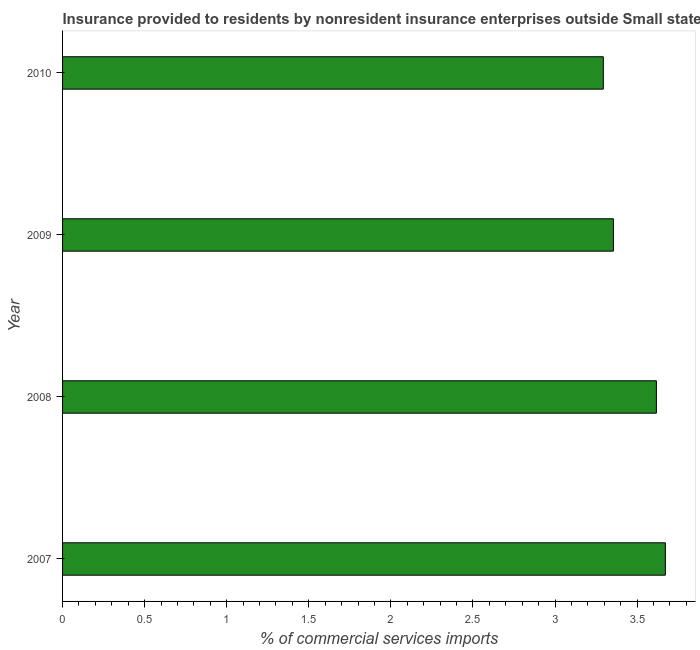What is the title of the graph?
Your response must be concise. Insurance provided to residents by nonresident insurance enterprises outside Small states. What is the label or title of the X-axis?
Make the answer very short. % of commercial services imports. What is the label or title of the Y-axis?
Offer a terse response. Year. What is the insurance provided by non-residents in 2009?
Give a very brief answer. 3.36. Across all years, what is the maximum insurance provided by non-residents?
Your answer should be very brief. 3.67. Across all years, what is the minimum insurance provided by non-residents?
Offer a terse response. 3.29. In which year was the insurance provided by non-residents minimum?
Provide a short and direct response. 2010. What is the sum of the insurance provided by non-residents?
Provide a short and direct response. 13.94. What is the difference between the insurance provided by non-residents in 2008 and 2010?
Keep it short and to the point. 0.32. What is the average insurance provided by non-residents per year?
Provide a short and direct response. 3.48. What is the median insurance provided by non-residents?
Keep it short and to the point. 3.49. In how many years, is the insurance provided by non-residents greater than 0.7 %?
Provide a short and direct response. 4. What is the ratio of the insurance provided by non-residents in 2009 to that in 2010?
Ensure brevity in your answer.  1.02. Is the insurance provided by non-residents in 2007 less than that in 2008?
Ensure brevity in your answer.  No. What is the difference between the highest and the second highest insurance provided by non-residents?
Provide a short and direct response. 0.06. Is the sum of the insurance provided by non-residents in 2009 and 2010 greater than the maximum insurance provided by non-residents across all years?
Provide a succinct answer. Yes. What is the difference between the highest and the lowest insurance provided by non-residents?
Your answer should be very brief. 0.38. What is the difference between two consecutive major ticks on the X-axis?
Offer a terse response. 0.5. What is the % of commercial services imports of 2007?
Make the answer very short. 3.67. What is the % of commercial services imports of 2008?
Make the answer very short. 3.62. What is the % of commercial services imports of 2009?
Your response must be concise. 3.36. What is the % of commercial services imports of 2010?
Ensure brevity in your answer.  3.29. What is the difference between the % of commercial services imports in 2007 and 2008?
Your answer should be very brief. 0.05. What is the difference between the % of commercial services imports in 2007 and 2009?
Your response must be concise. 0.32. What is the difference between the % of commercial services imports in 2007 and 2010?
Your answer should be compact. 0.38. What is the difference between the % of commercial services imports in 2008 and 2009?
Your response must be concise. 0.26. What is the difference between the % of commercial services imports in 2008 and 2010?
Ensure brevity in your answer.  0.32. What is the difference between the % of commercial services imports in 2009 and 2010?
Offer a very short reply. 0.06. What is the ratio of the % of commercial services imports in 2007 to that in 2009?
Give a very brief answer. 1.09. What is the ratio of the % of commercial services imports in 2007 to that in 2010?
Offer a very short reply. 1.11. What is the ratio of the % of commercial services imports in 2008 to that in 2009?
Keep it short and to the point. 1.08. What is the ratio of the % of commercial services imports in 2008 to that in 2010?
Your answer should be very brief. 1.1. What is the ratio of the % of commercial services imports in 2009 to that in 2010?
Give a very brief answer. 1.02. 